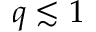<formula> <loc_0><loc_0><loc_500><loc_500>q \lesssim 1</formula> 